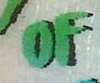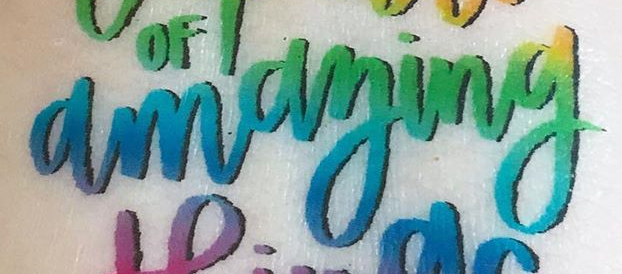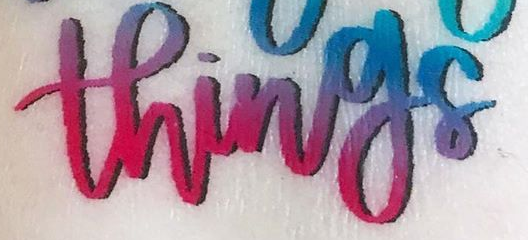What words are shown in these images in order, separated by a semicolon? OF; amaying; things 